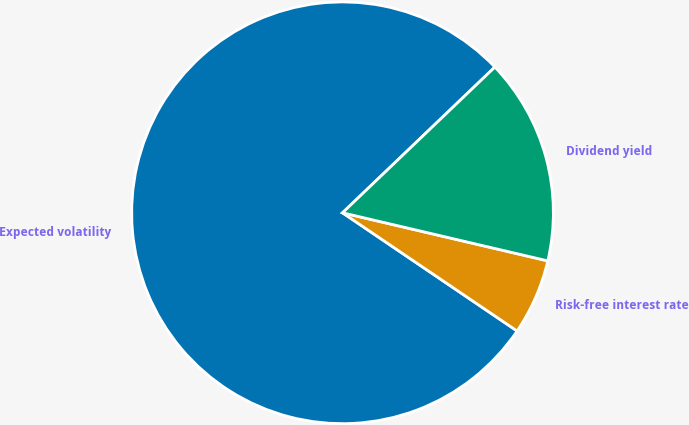Convert chart to OTSL. <chart><loc_0><loc_0><loc_500><loc_500><pie_chart><fcel>Expected volatility<fcel>Risk-free interest rate<fcel>Dividend yield<nl><fcel>78.39%<fcel>5.81%<fcel>15.81%<nl></chart> 